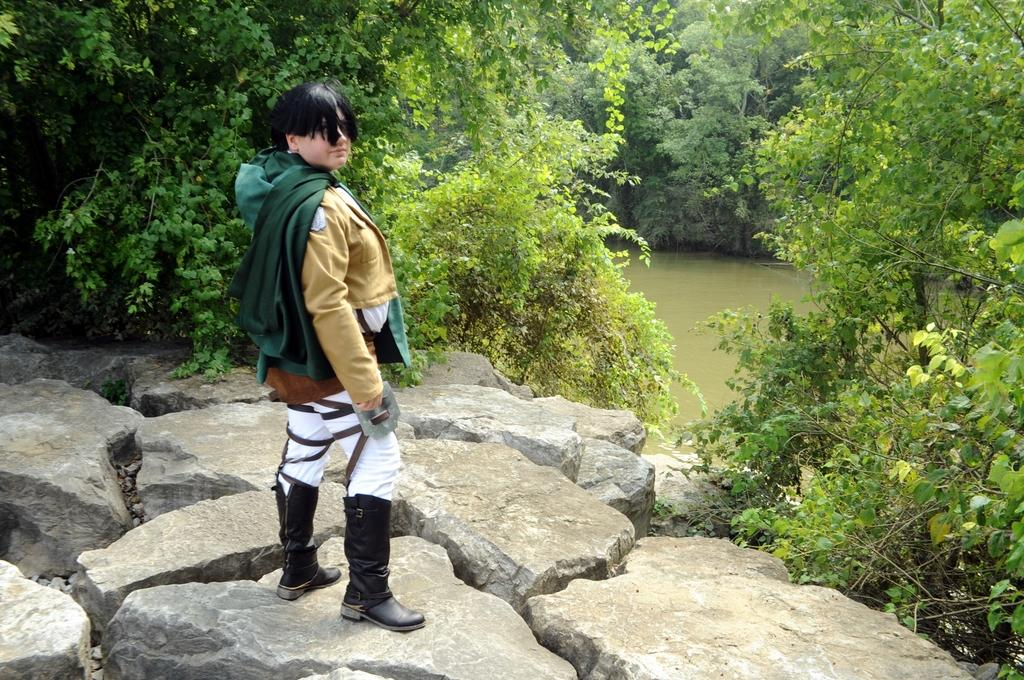Who is present in the image? There is a person in the image. What is the person wearing? The person is wearing a brown, green, and white dress. Where is the person standing? The person is standing on a rock. What can be seen in the background of the image? There are many trees and water visible in the background of the image. What type of silver jewelry is the person wearing in the image? There is no silver jewelry visible on the person in the image. 